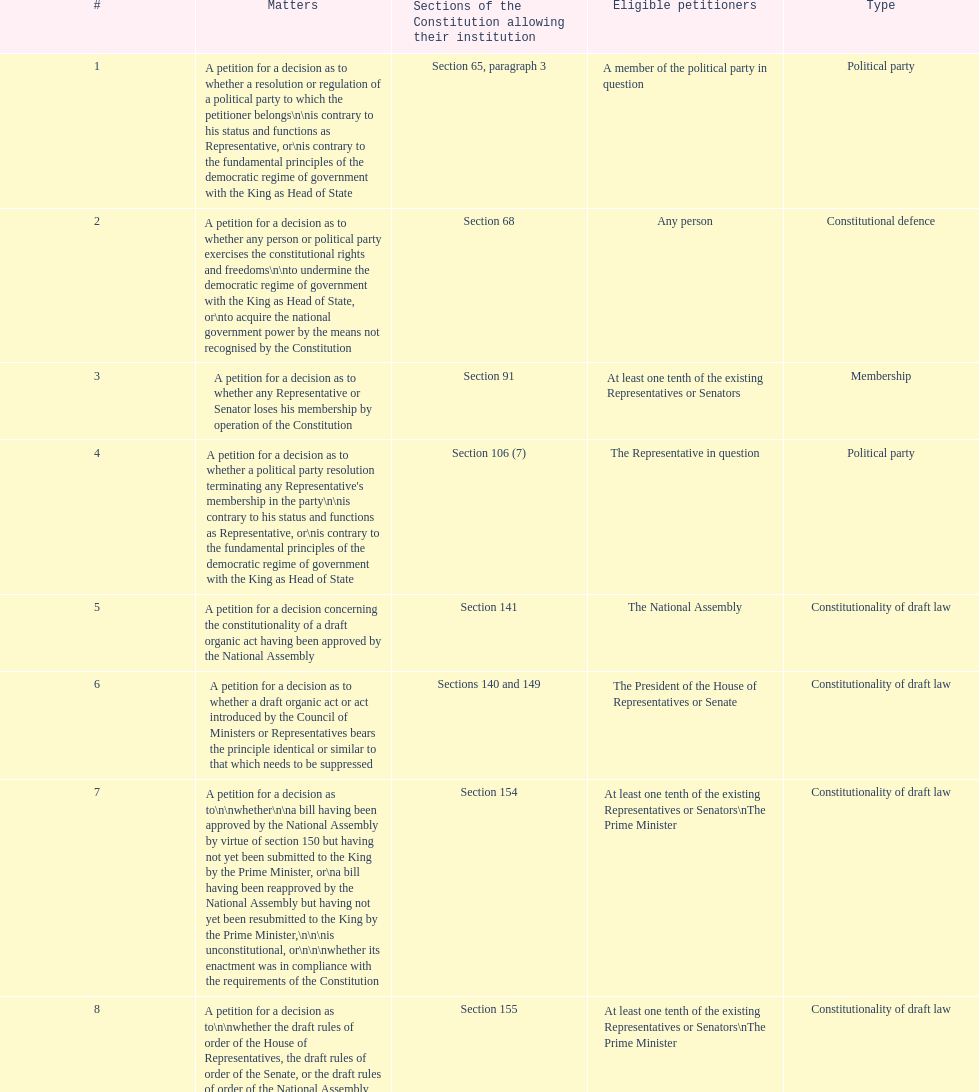How many matters have political party as their "type"? 3. 